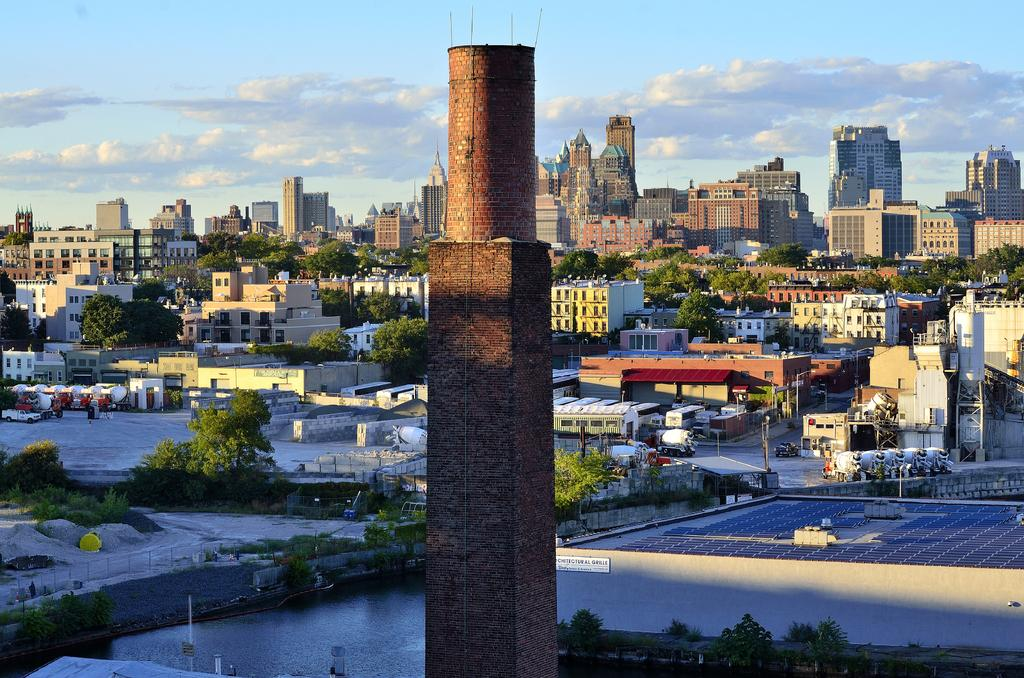What type of structures can be seen in the image? There are buildings in the image. What natural elements are present in the image? There are trees and plants in the image. What specific feature can be identified in the image? There is a tower in the image. What is written or displayed on a surface in the image? There is a board with text on a wall in the image. What body of water is visible in the image? There is water visible in the image. What type of transportation can be seen in the image? There are cars in the image. What is the color and condition of the sky in the image? The sky is blue and cloudy in the image. How does the respect for the drawer impact the answer in the image? There is no mention of respect or a drawer in the image, so this question cannot be answered. 